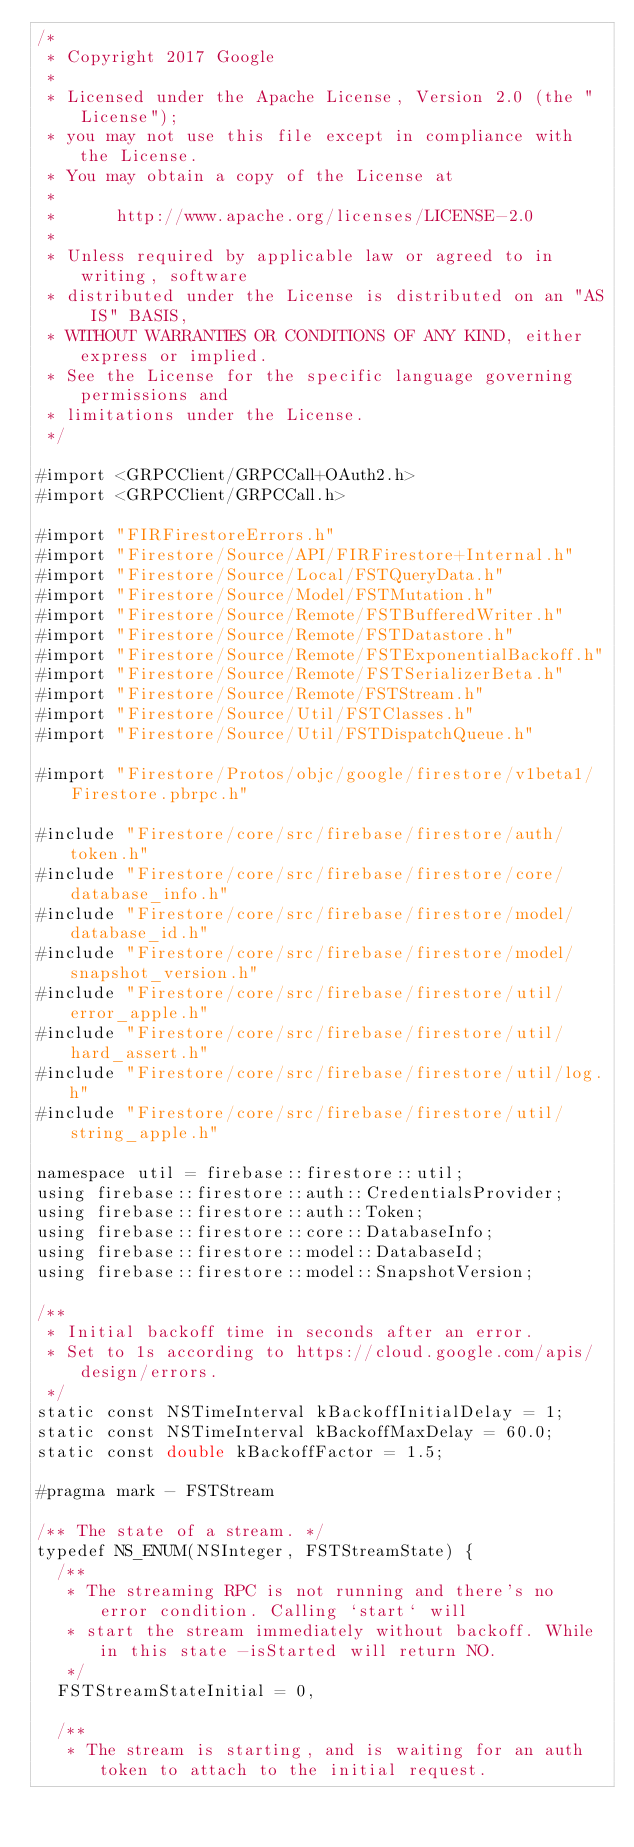<code> <loc_0><loc_0><loc_500><loc_500><_ObjectiveC_>/*
 * Copyright 2017 Google
 *
 * Licensed under the Apache License, Version 2.0 (the "License");
 * you may not use this file except in compliance with the License.
 * You may obtain a copy of the License at
 *
 *      http://www.apache.org/licenses/LICENSE-2.0
 *
 * Unless required by applicable law or agreed to in writing, software
 * distributed under the License is distributed on an "AS IS" BASIS,
 * WITHOUT WARRANTIES OR CONDITIONS OF ANY KIND, either express or implied.
 * See the License for the specific language governing permissions and
 * limitations under the License.
 */

#import <GRPCClient/GRPCCall+OAuth2.h>
#import <GRPCClient/GRPCCall.h>

#import "FIRFirestoreErrors.h"
#import "Firestore/Source/API/FIRFirestore+Internal.h"
#import "Firestore/Source/Local/FSTQueryData.h"
#import "Firestore/Source/Model/FSTMutation.h"
#import "Firestore/Source/Remote/FSTBufferedWriter.h"
#import "Firestore/Source/Remote/FSTDatastore.h"
#import "Firestore/Source/Remote/FSTExponentialBackoff.h"
#import "Firestore/Source/Remote/FSTSerializerBeta.h"
#import "Firestore/Source/Remote/FSTStream.h"
#import "Firestore/Source/Util/FSTClasses.h"
#import "Firestore/Source/Util/FSTDispatchQueue.h"

#import "Firestore/Protos/objc/google/firestore/v1beta1/Firestore.pbrpc.h"

#include "Firestore/core/src/firebase/firestore/auth/token.h"
#include "Firestore/core/src/firebase/firestore/core/database_info.h"
#include "Firestore/core/src/firebase/firestore/model/database_id.h"
#include "Firestore/core/src/firebase/firestore/model/snapshot_version.h"
#include "Firestore/core/src/firebase/firestore/util/error_apple.h"
#include "Firestore/core/src/firebase/firestore/util/hard_assert.h"
#include "Firestore/core/src/firebase/firestore/util/log.h"
#include "Firestore/core/src/firebase/firestore/util/string_apple.h"

namespace util = firebase::firestore::util;
using firebase::firestore::auth::CredentialsProvider;
using firebase::firestore::auth::Token;
using firebase::firestore::core::DatabaseInfo;
using firebase::firestore::model::DatabaseId;
using firebase::firestore::model::SnapshotVersion;

/**
 * Initial backoff time in seconds after an error.
 * Set to 1s according to https://cloud.google.com/apis/design/errors.
 */
static const NSTimeInterval kBackoffInitialDelay = 1;
static const NSTimeInterval kBackoffMaxDelay = 60.0;
static const double kBackoffFactor = 1.5;

#pragma mark - FSTStream

/** The state of a stream. */
typedef NS_ENUM(NSInteger, FSTStreamState) {
  /**
   * The streaming RPC is not running and there's no error condition. Calling `start` will
   * start the stream immediately without backoff. While in this state -isStarted will return NO.
   */
  FSTStreamStateInitial = 0,

  /**
   * The stream is starting, and is waiting for an auth token to attach to the initial request.</code> 